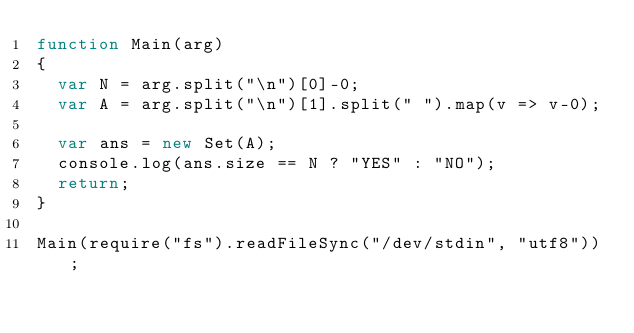<code> <loc_0><loc_0><loc_500><loc_500><_JavaScript_>function Main(arg)
{
  var N = arg.split("\n")[0]-0;
  var A = arg.split("\n")[1].split(" ").map(v => v-0);

  var ans = new Set(A);
  console.log(ans.size == N ? "YES" : "NO");
  return;
}

Main(require("fs").readFileSync("/dev/stdin", "utf8"));</code> 